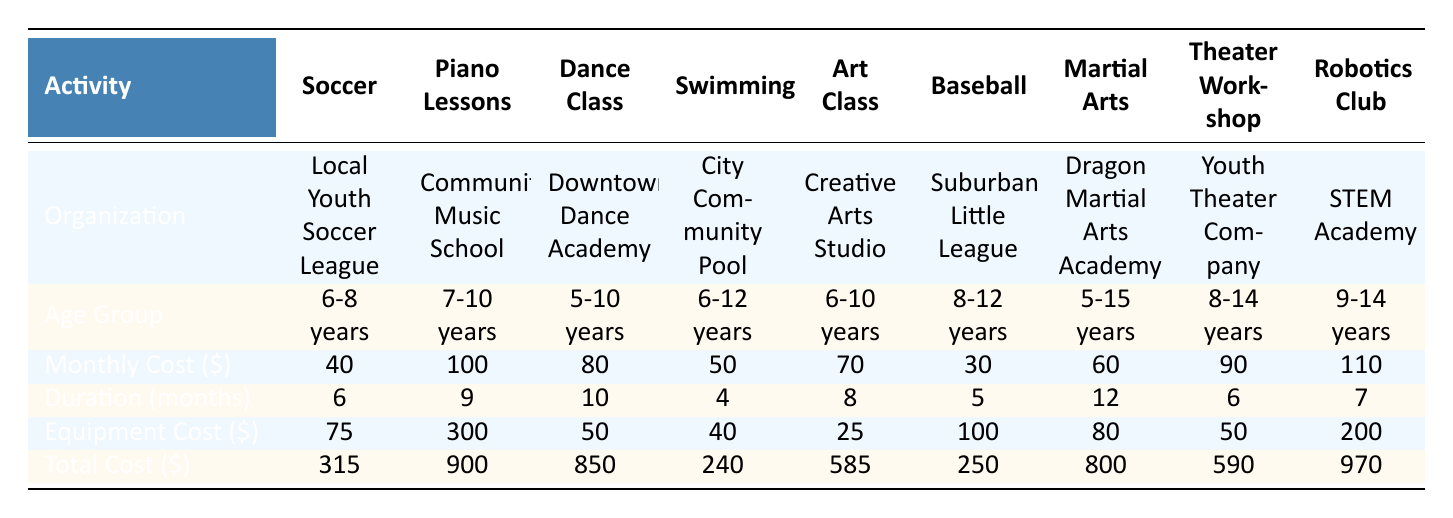What is the total cost for Soccer? In the table, under the total cost column for Soccer, the value is shown as 315.
Answer: 315 What organization offers Piano Lessons? Looking at the organization column under Piano Lessons, it is labeled Community Music School.
Answer: Community Music School What is the equipment cost for Dance Class? The equipment cost for Dance Class in the corresponding column is 50.
Answer: 50 Which activity has the highest monthly cost? By comparing the monthly costs, Robotics Club has the highest monthly cost of 110.
Answer: 110 How many months does the Martial Arts program last? The duration for Martial Arts is listed in the table as 12 months.
Answer: 12 Is the total cost for Girl Scouts less than 200? The total cost for Girl Scouts is 155, which is indeed less than 200.
Answer: Yes What is the average monthly cost of all activities listed? The average monthly cost can be calculated by first summing all the monthly costs (40 + 100 + 80 + 50 + 70 + 30 + 60 + 90 + 110 = 630). There are 9 activities, so average is 630 / 9 = 70.
Answer: 70 If a child participates in both Art Class and Robotics Club, what would be their total cost? The total cost for Art Class is 585 and for Robotics Club is 970. Adding these gives 585 + 970 = 1555.
Answer: 1555 What is the age range for students in the Swimming activity? The age group listed for Swimming is 6-12 years.
Answer: 6-12 years Which activity has the lowest total cost? The total costs for each activity show Girl Scouts with the lowest total cost of 155.
Answer: 155 How much more does Piano Lessons cost compared to Baseball? The total cost for Piano Lessons is 900 and for Baseball is 250. The difference is 900 - 250 = 650.
Answer: 650 Which activities fall within the age group of 5-10 years? The activities that fit this age group are Dance Class, Art Class, and Girl Scouts.
Answer: Dance Class, Art Class, Girl Scouts What is the combined equipment cost for Dance Class and Swimming? The equipment cost for Dance Class is 50 and for Swimming it is 40. Adding these gives 50 + 40 = 90.
Answer: 90 Is the monthly cost for Robotics Club higher than that of Soccer? The monthly cost for Robotics Club is 110 while Soccer is 40, indicating that Robotics Club is indeed higher.
Answer: Yes What is the total duration for all activities? The duration for each activity is summed: (6 + 9 + 10 + 4 + 8 + 5 + 12 + 6 + 7 = 67).
Answer: 67 